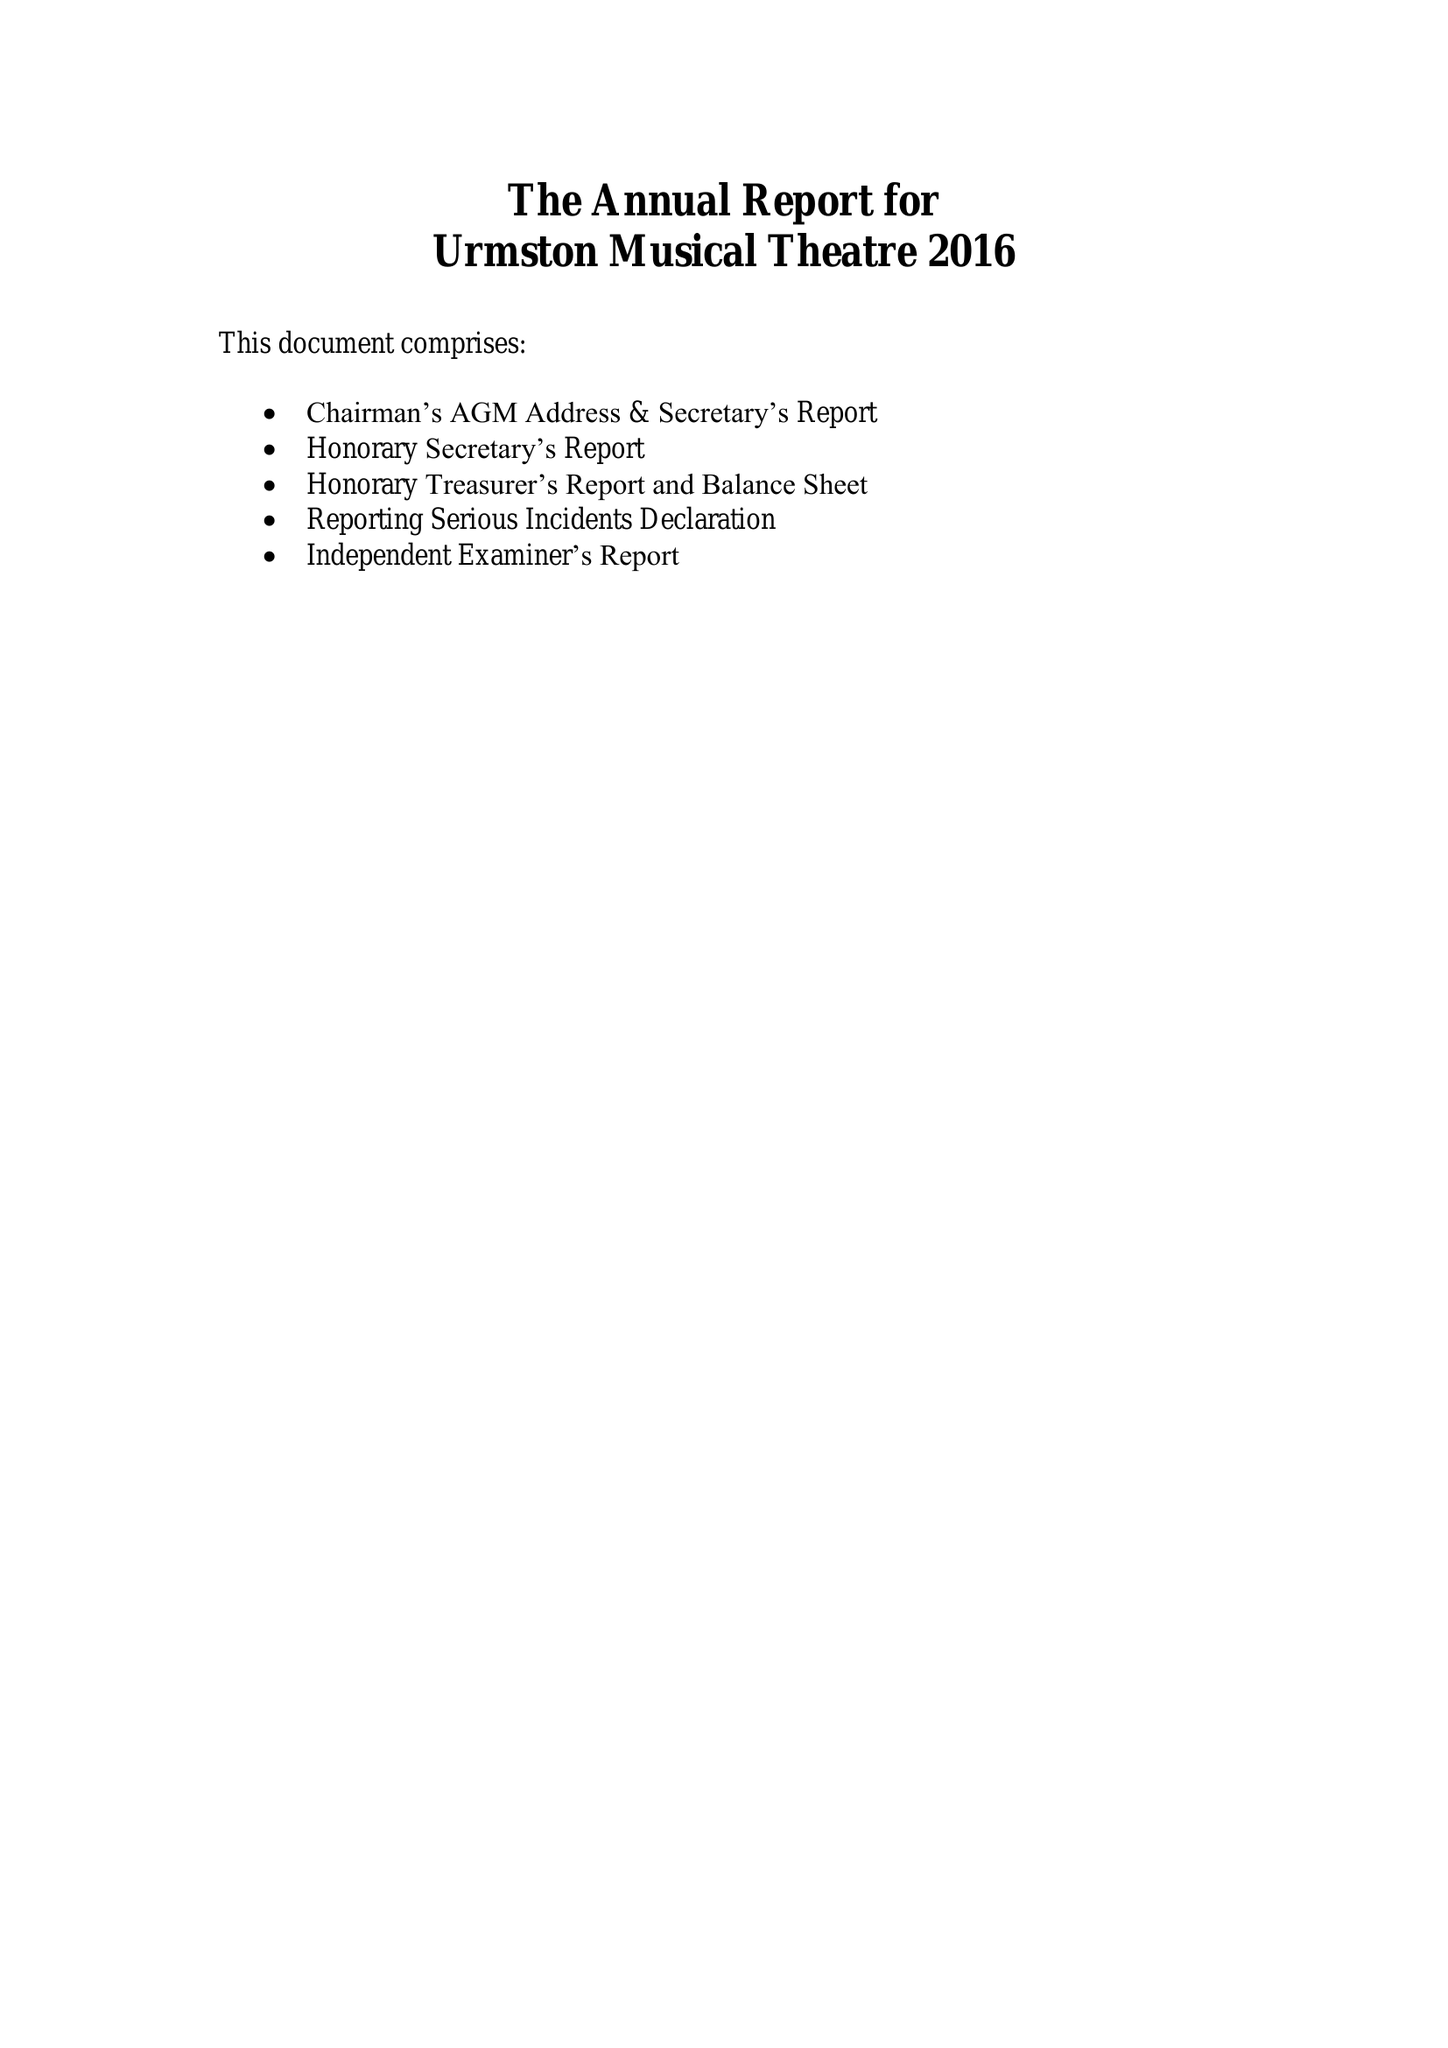What is the value for the address__post_town?
Answer the question using a single word or phrase. MANCHESTER 